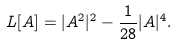<formula> <loc_0><loc_0><loc_500><loc_500>L [ A ] = | A ^ { 2 } | ^ { 2 } - \frac { 1 } { 2 8 } | A | ^ { 4 } .</formula> 